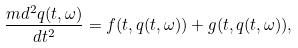<formula> <loc_0><loc_0><loc_500><loc_500>\frac { m d ^ { 2 } q ( t , \omega ) } { d t ^ { 2 } } = f ( t , q ( t , \omega ) ) + g ( t , q ( t , \omega ) ) ,</formula> 